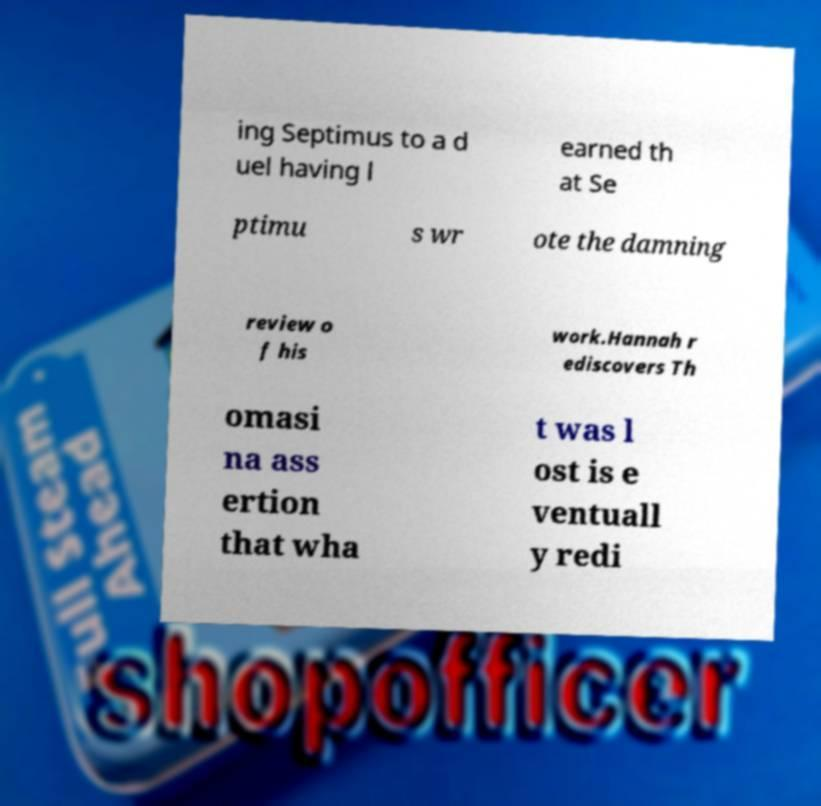Please read and relay the text visible in this image. What does it say? ing Septimus to a d uel having l earned th at Se ptimu s wr ote the damning review o f his work.Hannah r ediscovers Th omasi na ass ertion that wha t was l ost is e ventuall y redi 